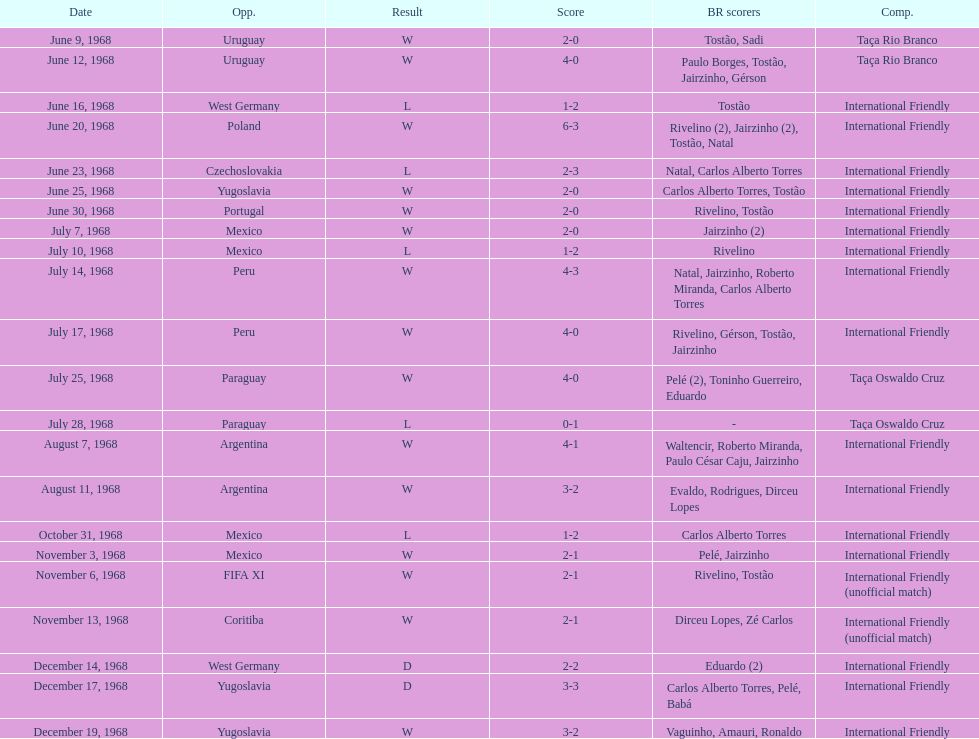What is the maximum score ever attained by the national team of brazil? 6. 